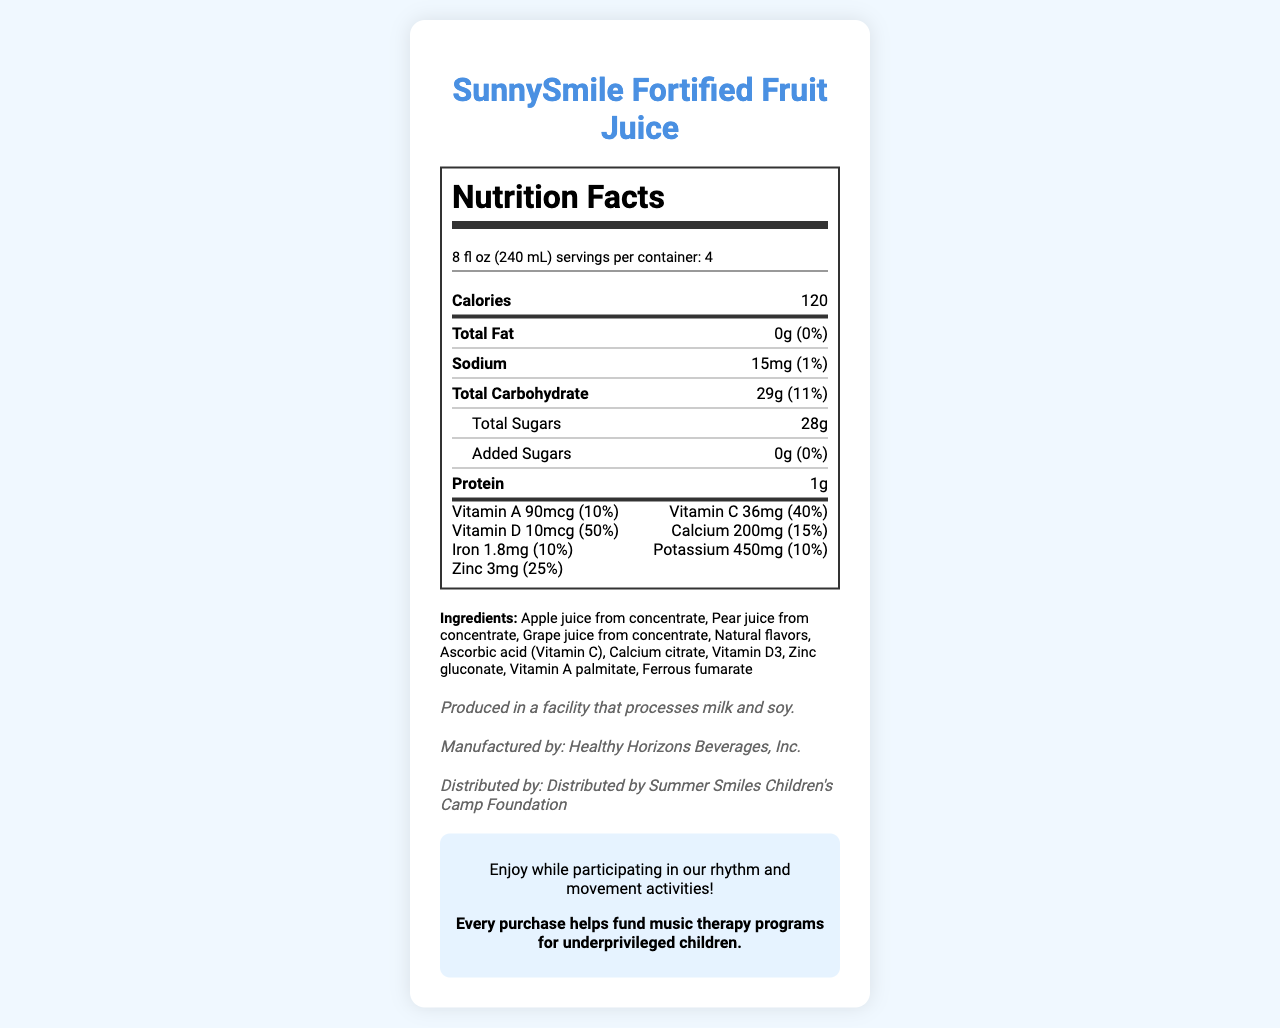what is the serving size? The document indicates that the serving size is 8 fl oz (240 mL) under the section titled 'serving size'.
Answer: 8 fl oz (240 mL) how many servings are there per container? The document lists 'servings per container' directly under the serving size, which is 4.
Answer: 4 total calories per serving? The document states 'Calories' as 120 in the nutritional values section.
Answer: 120 how much protein is in one serving of the juice? The amount of protein per serving is listed as 1g in the document.
Answer: 1g how much vitamin C does this juice provide per serving? The document indicates that each serving contains 36mg of Vitamin C, accounting for 40% of the daily value.
Answer: 36mg (40%) which company manufactures SunnySmile Fortified Fruit Juice? A. Summer Smiles Children's Camp Foundation B. Healthy Horizons Beverages, Inc. C. SunnySmile Corporation D. FruitJuice Co. The manufacturer information indicates that Healthy Horizons Beverages, Inc. is responsible for manufacturing the juice.
Answer: B. Healthy Horizons Beverages, Inc. what is the percentage of daily value for calcium per serving? A. 5% B. 10% C. 15% D. 20% The document lists calcium with an amount of 200mg, which corresponds to 15% of the daily value.
Answer: C. 15% is there any added sugar in this juice? According to the nutritional information, the document specifies 'Added Sugars' as 0g (0% of daily value), indicating there is no added sugar.
Answer: No does this juice contain any artificial flavors? The ingredient list only mentions "Natural flavors" and does not reference any artificial flavors.
Answer: No what additional benefit does the purchase of this juice provide? The social impact note at the bottom of the document states that every purchase helps fund music therapy programs for underprivileged children.
Answer: Helps fund music therapy programs for underprivileged children describe the main idea of the document. The document is formatted to display the nutritional values and ingredients clearly, and it also includes additional information that emphasizes both the enjoyment of the juice during music therapy activities and the social impact of contributing to children's well-being.
Answer: The document provides nutrition facts, ingredients, allergen information, manufacturer details, and social impact notes for SunnySmile Fortified Fruit Juice. It highlights the juice's nutritional benefits, including its vitamins and minerals, while mentioning its role in supporting music therapy programs for underprivileged children. what is the production facility's allergen warning? The allergen information section of the document states that the juice is produced in a facility that processes milk and soy.
Answer: Produced in a facility that processes milk and soy. how much potassium is in one serving? The document lists potassium as 450mg per serving, accounting for 10% of the daily value.
Answer: 450mg (10%) can it be determined if this juice contains any preservatives from the document? The ingredient list and other sections do not specify whether preservatives are included, so this information cannot be determined from the document.
Answer: Cannot be determined who distributes SunnySmile Fortified Fruit Juice? The document mentions that the juice is distributed by the Summer Smiles Children's Camp Foundation.
Answer: Summer Smiles Children's Camp Foundation 